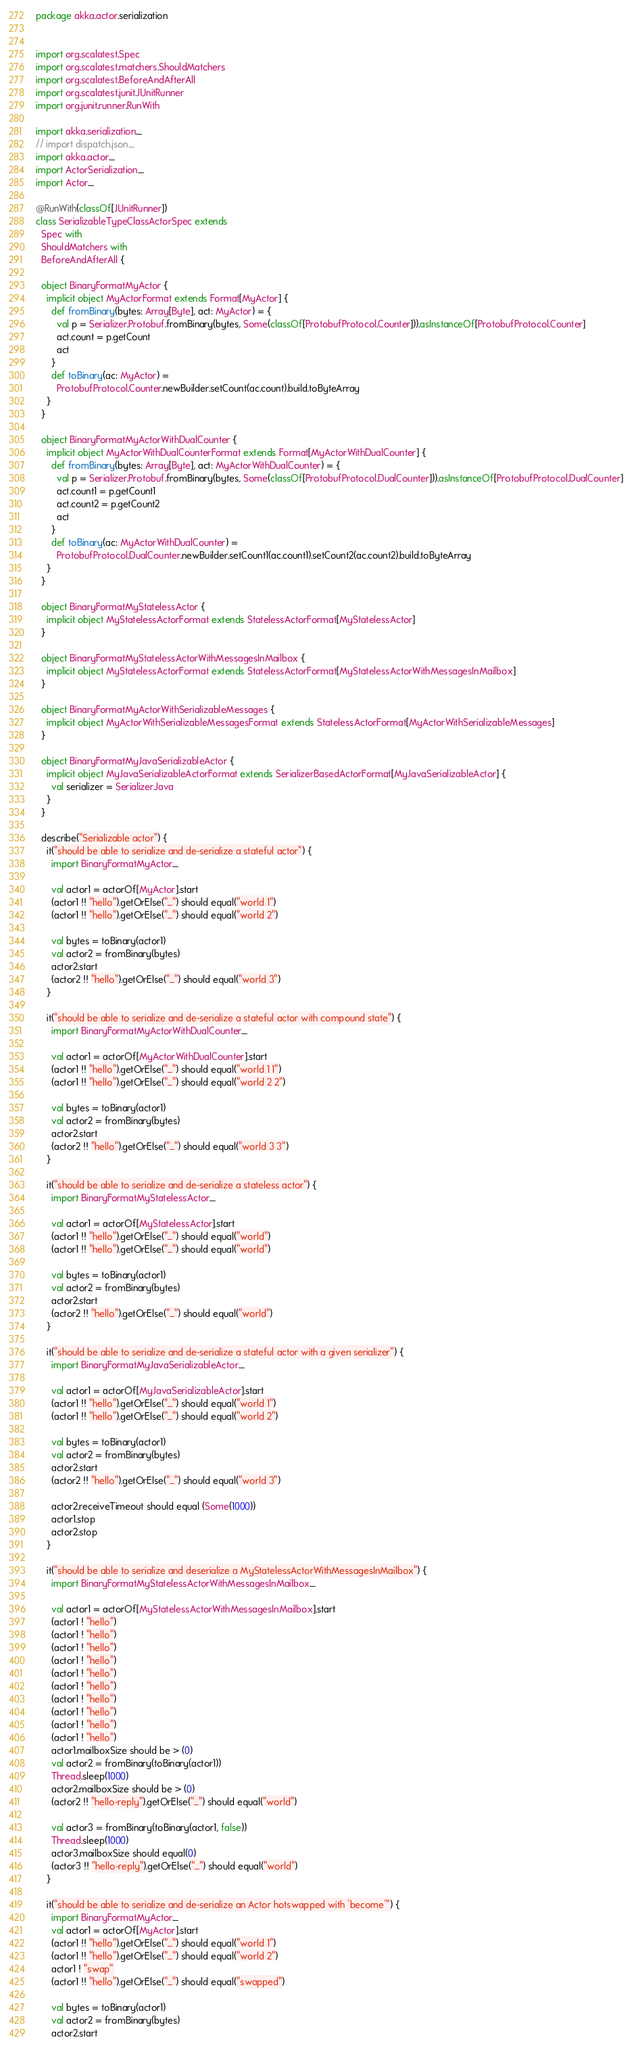Convert code to text. <code><loc_0><loc_0><loc_500><loc_500><_Scala_>package akka.actor.serialization


import org.scalatest.Spec
import org.scalatest.matchers.ShouldMatchers
import org.scalatest.BeforeAndAfterAll
import org.scalatest.junit.JUnitRunner
import org.junit.runner.RunWith

import akka.serialization._
// import dispatch.json._
import akka.actor._
import ActorSerialization._
import Actor._

@RunWith(classOf[JUnitRunner])
class SerializableTypeClassActorSpec extends
  Spec with
  ShouldMatchers with
  BeforeAndAfterAll {

  object BinaryFormatMyActor {
    implicit object MyActorFormat extends Format[MyActor] {
      def fromBinary(bytes: Array[Byte], act: MyActor) = {
        val p = Serializer.Protobuf.fromBinary(bytes, Some(classOf[ProtobufProtocol.Counter])).asInstanceOf[ProtobufProtocol.Counter]
        act.count = p.getCount
        act
      }
      def toBinary(ac: MyActor) =
        ProtobufProtocol.Counter.newBuilder.setCount(ac.count).build.toByteArray
    }
  }

  object BinaryFormatMyActorWithDualCounter {
    implicit object MyActorWithDualCounterFormat extends Format[MyActorWithDualCounter] {
      def fromBinary(bytes: Array[Byte], act: MyActorWithDualCounter) = {
        val p = Serializer.Protobuf.fromBinary(bytes, Some(classOf[ProtobufProtocol.DualCounter])).asInstanceOf[ProtobufProtocol.DualCounter]
        act.count1 = p.getCount1
        act.count2 = p.getCount2
        act
      }
      def toBinary(ac: MyActorWithDualCounter) =
        ProtobufProtocol.DualCounter.newBuilder.setCount1(ac.count1).setCount2(ac.count2).build.toByteArray
    }
  }

  object BinaryFormatMyStatelessActor {
    implicit object MyStatelessActorFormat extends StatelessActorFormat[MyStatelessActor]
  }

  object BinaryFormatMyStatelessActorWithMessagesInMailbox {
    implicit object MyStatelessActorFormat extends StatelessActorFormat[MyStatelessActorWithMessagesInMailbox]
  }

  object BinaryFormatMyActorWithSerializableMessages {
    implicit object MyActorWithSerializableMessagesFormat extends StatelessActorFormat[MyActorWithSerializableMessages]
  }

  object BinaryFormatMyJavaSerializableActor {
    implicit object MyJavaSerializableActorFormat extends SerializerBasedActorFormat[MyJavaSerializableActor] {
      val serializer = Serializer.Java
    }
  }

  describe("Serializable actor") {
    it("should be able to serialize and de-serialize a stateful actor") {
      import BinaryFormatMyActor._

      val actor1 = actorOf[MyActor].start
      (actor1 !! "hello").getOrElse("_") should equal("world 1")
      (actor1 !! "hello").getOrElse("_") should equal("world 2")

      val bytes = toBinary(actor1)
      val actor2 = fromBinary(bytes)
      actor2.start
      (actor2 !! "hello").getOrElse("_") should equal("world 3")
    }

    it("should be able to serialize and de-serialize a stateful actor with compound state") {
      import BinaryFormatMyActorWithDualCounter._

      val actor1 = actorOf[MyActorWithDualCounter].start
      (actor1 !! "hello").getOrElse("_") should equal("world 1 1")
      (actor1 !! "hello").getOrElse("_") should equal("world 2 2")

      val bytes = toBinary(actor1)
      val actor2 = fromBinary(bytes)
      actor2.start
      (actor2 !! "hello").getOrElse("_") should equal("world 3 3")
    }

    it("should be able to serialize and de-serialize a stateless actor") {
      import BinaryFormatMyStatelessActor._

      val actor1 = actorOf[MyStatelessActor].start
      (actor1 !! "hello").getOrElse("_") should equal("world")
      (actor1 !! "hello").getOrElse("_") should equal("world")

      val bytes = toBinary(actor1)
      val actor2 = fromBinary(bytes)
      actor2.start
      (actor2 !! "hello").getOrElse("_") should equal("world")
    }

    it("should be able to serialize and de-serialize a stateful actor with a given serializer") {
      import BinaryFormatMyJavaSerializableActor._

      val actor1 = actorOf[MyJavaSerializableActor].start
      (actor1 !! "hello").getOrElse("_") should equal("world 1")
      (actor1 !! "hello").getOrElse("_") should equal("world 2")

      val bytes = toBinary(actor1)
      val actor2 = fromBinary(bytes)
      actor2.start
      (actor2 !! "hello").getOrElse("_") should equal("world 3")

      actor2.receiveTimeout should equal (Some(1000))
      actor1.stop
      actor2.stop
    }

    it("should be able to serialize and deserialize a MyStatelessActorWithMessagesInMailbox") {
      import BinaryFormatMyStatelessActorWithMessagesInMailbox._

      val actor1 = actorOf[MyStatelessActorWithMessagesInMailbox].start
      (actor1 ! "hello")
      (actor1 ! "hello")
      (actor1 ! "hello")
      (actor1 ! "hello")
      (actor1 ! "hello")
      (actor1 ! "hello")
      (actor1 ! "hello")
      (actor1 ! "hello")
      (actor1 ! "hello")
      (actor1 ! "hello")
      actor1.mailboxSize should be > (0)
      val actor2 = fromBinary(toBinary(actor1))
      Thread.sleep(1000)
      actor2.mailboxSize should be > (0)
      (actor2 !! "hello-reply").getOrElse("_") should equal("world")

      val actor3 = fromBinary(toBinary(actor1, false))
      Thread.sleep(1000)
      actor3.mailboxSize should equal(0)
      (actor3 !! "hello-reply").getOrElse("_") should equal("world")
    }

    it("should be able to serialize and de-serialize an Actor hotswapped with 'become'") {
      import BinaryFormatMyActor._
      val actor1 = actorOf[MyActor].start
      (actor1 !! "hello").getOrElse("_") should equal("world 1")
      (actor1 !! "hello").getOrElse("_") should equal("world 2")
      actor1 ! "swap"
      (actor1 !! "hello").getOrElse("_") should equal("swapped")

      val bytes = toBinary(actor1)
      val actor2 = fromBinary(bytes)
      actor2.start
</code> 